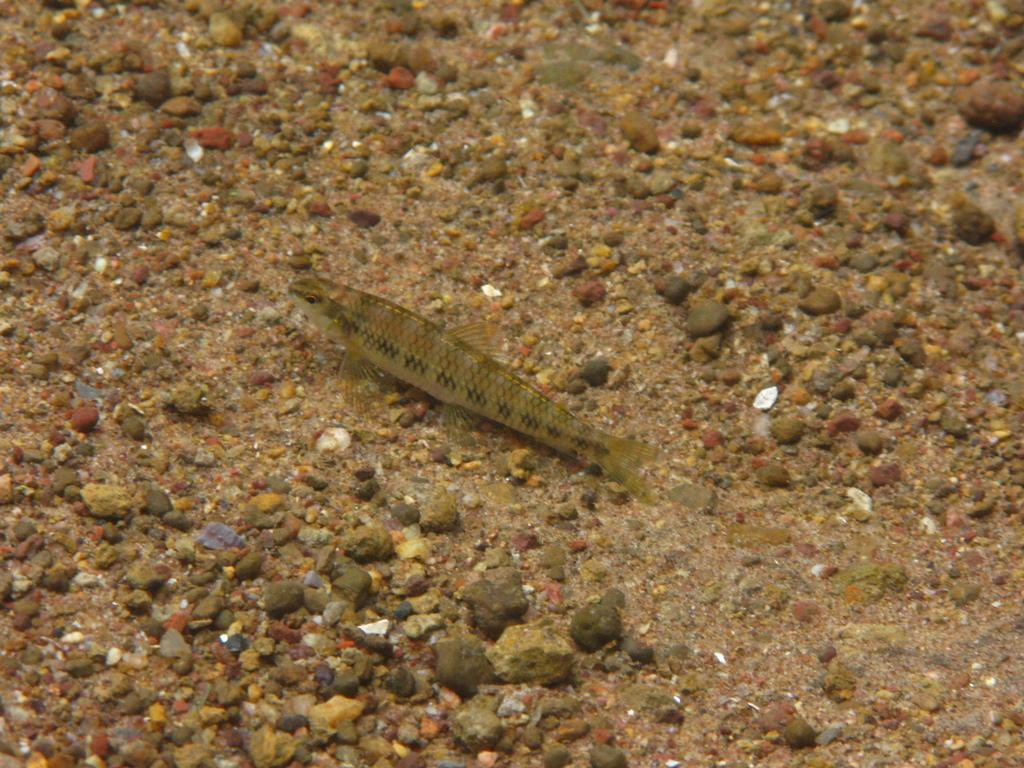What type of objects can be seen in the image? There are stones in the image. Are there any living creatures present in the image? Yes, there is a fish in the image. What is the mass of the cent in the middle of the image? There is no cent present in the image, and therefore no mass can be determined. 